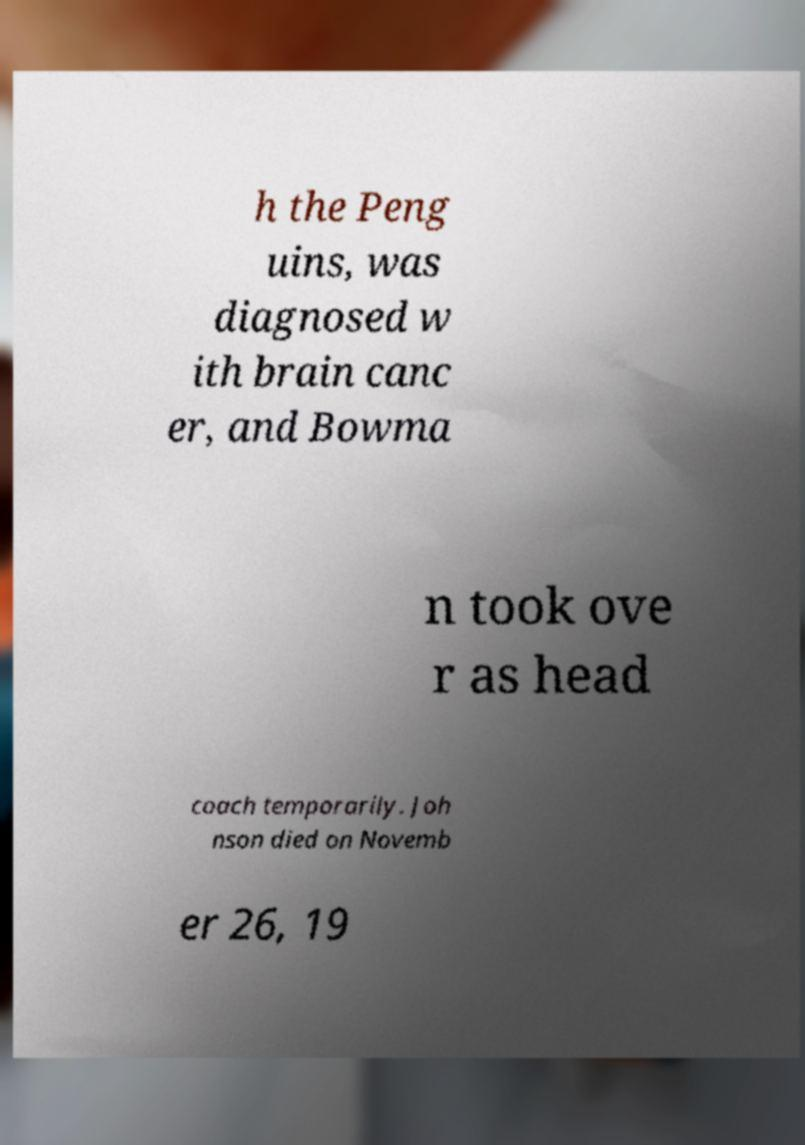I need the written content from this picture converted into text. Can you do that? h the Peng uins, was diagnosed w ith brain canc er, and Bowma n took ove r as head coach temporarily. Joh nson died on Novemb er 26, 19 